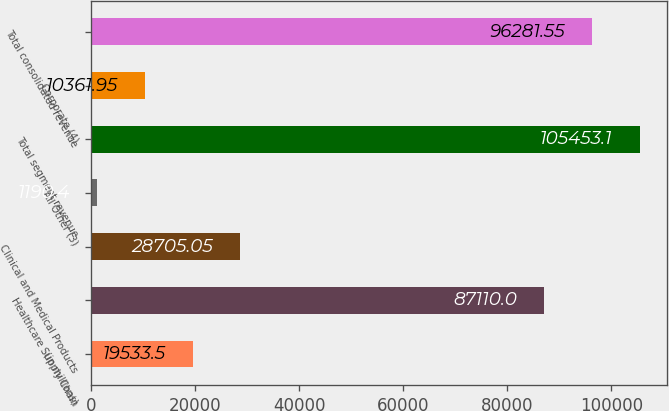Convert chart to OTSL. <chart><loc_0><loc_0><loc_500><loc_500><bar_chart><fcel>(in millions)<fcel>Healthcare Supply Chain<fcel>Clinical and Medical Products<fcel>All Other (3)<fcel>Total segment revenue<fcel>Corporate (4)<fcel>Total consolidated revenue<nl><fcel>19533.5<fcel>87110<fcel>28705<fcel>1190.4<fcel>105453<fcel>10362<fcel>96281.6<nl></chart> 